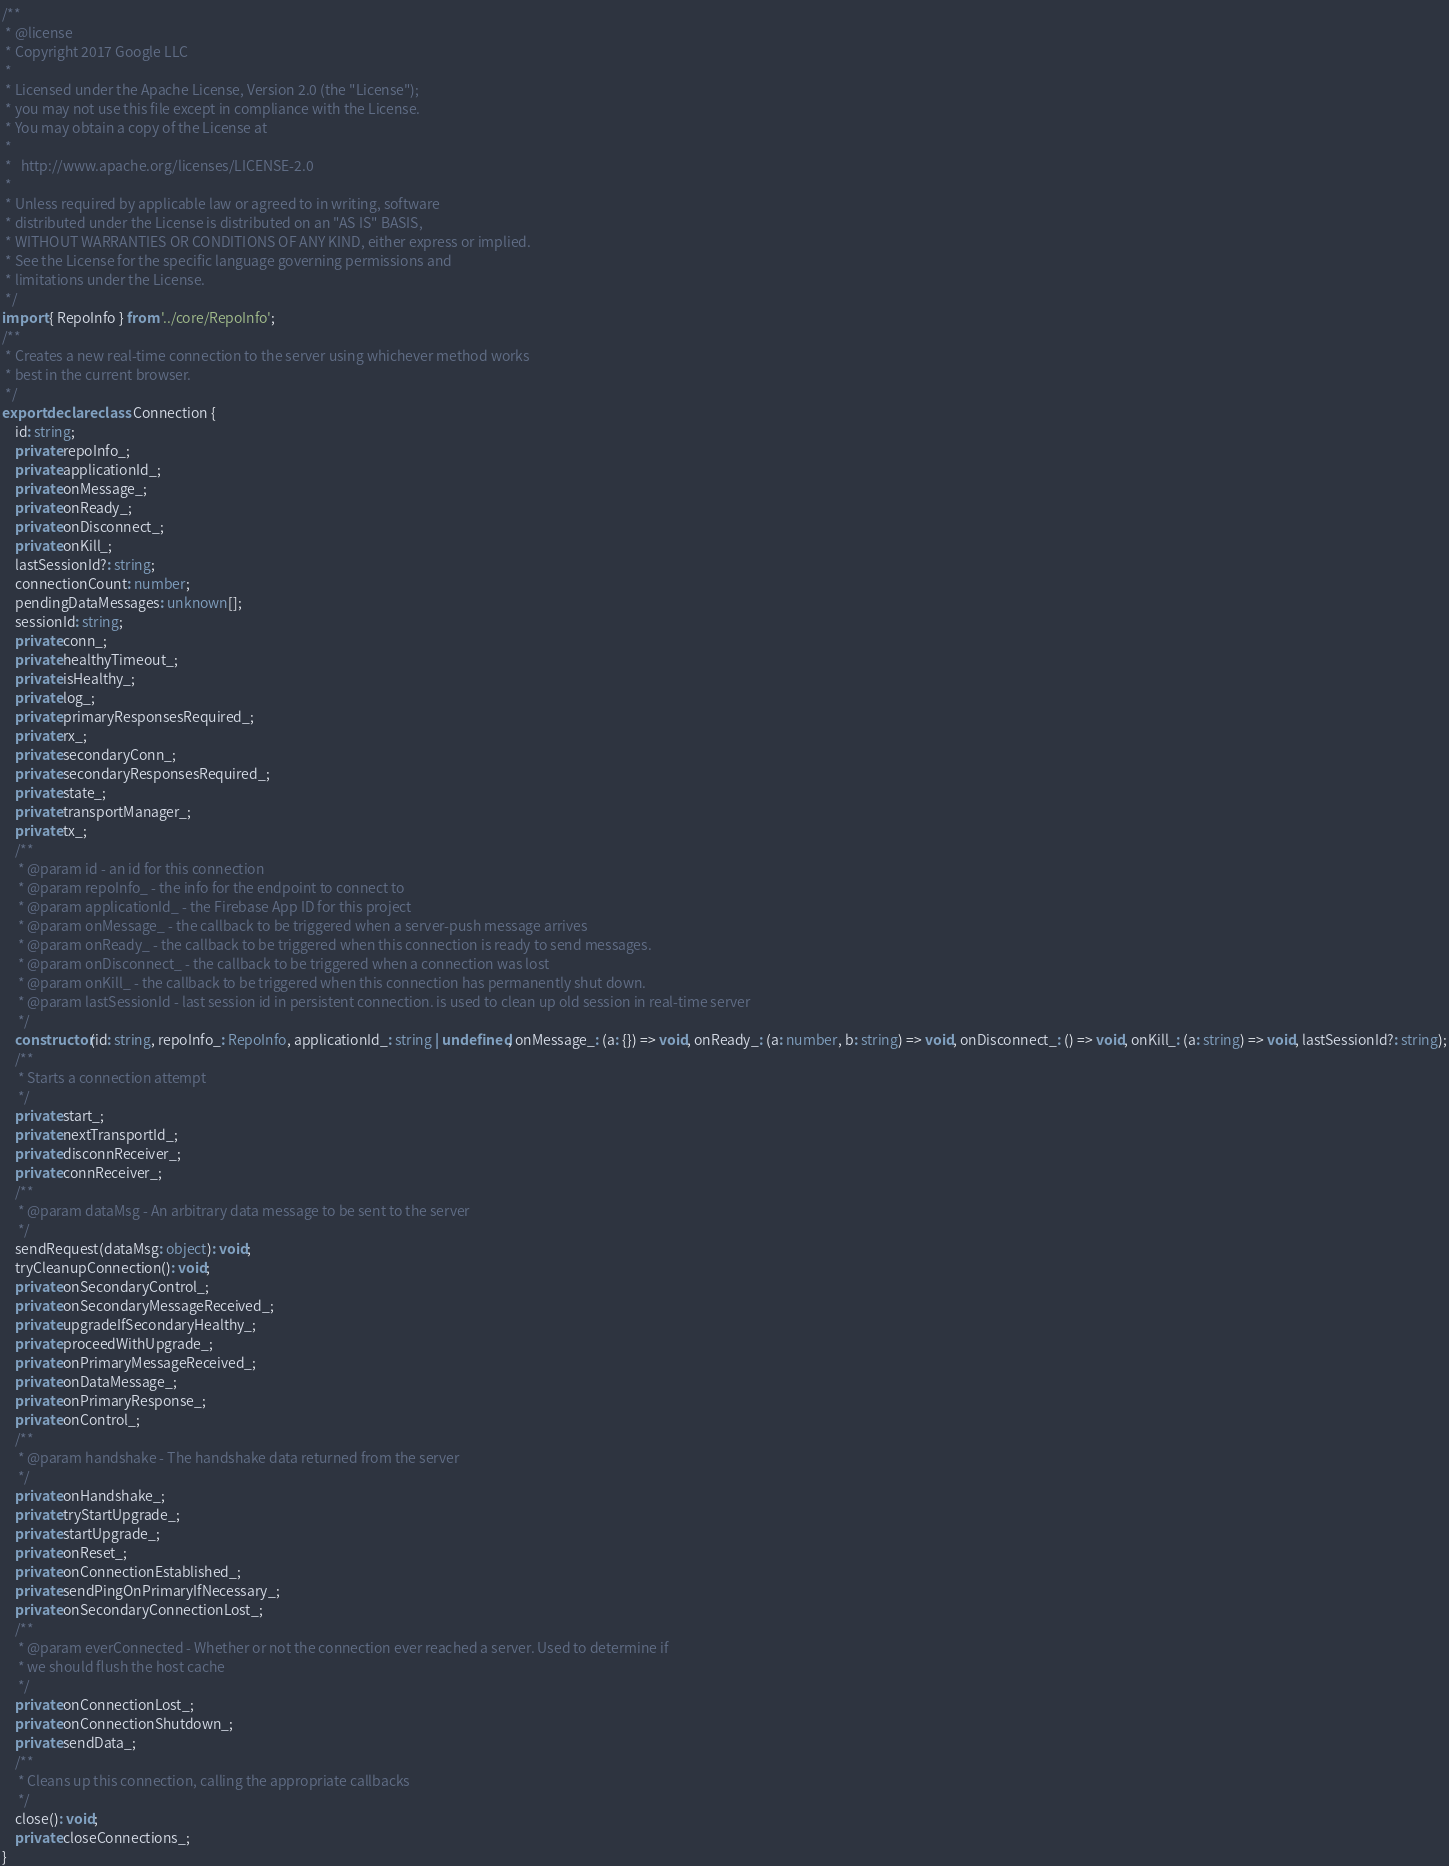<code> <loc_0><loc_0><loc_500><loc_500><_TypeScript_>/**
 * @license
 * Copyright 2017 Google LLC
 *
 * Licensed under the Apache License, Version 2.0 (the "License");
 * you may not use this file except in compliance with the License.
 * You may obtain a copy of the License at
 *
 *   http://www.apache.org/licenses/LICENSE-2.0
 *
 * Unless required by applicable law or agreed to in writing, software
 * distributed under the License is distributed on an "AS IS" BASIS,
 * WITHOUT WARRANTIES OR CONDITIONS OF ANY KIND, either express or implied.
 * See the License for the specific language governing permissions and
 * limitations under the License.
 */
import { RepoInfo } from '../core/RepoInfo';
/**
 * Creates a new real-time connection to the server using whichever method works
 * best in the current browser.
 */
export declare class Connection {
    id: string;
    private repoInfo_;
    private applicationId_;
    private onMessage_;
    private onReady_;
    private onDisconnect_;
    private onKill_;
    lastSessionId?: string;
    connectionCount: number;
    pendingDataMessages: unknown[];
    sessionId: string;
    private conn_;
    private healthyTimeout_;
    private isHealthy_;
    private log_;
    private primaryResponsesRequired_;
    private rx_;
    private secondaryConn_;
    private secondaryResponsesRequired_;
    private state_;
    private transportManager_;
    private tx_;
    /**
     * @param id - an id for this connection
     * @param repoInfo_ - the info for the endpoint to connect to
     * @param applicationId_ - the Firebase App ID for this project
     * @param onMessage_ - the callback to be triggered when a server-push message arrives
     * @param onReady_ - the callback to be triggered when this connection is ready to send messages.
     * @param onDisconnect_ - the callback to be triggered when a connection was lost
     * @param onKill_ - the callback to be triggered when this connection has permanently shut down.
     * @param lastSessionId - last session id in persistent connection. is used to clean up old session in real-time server
     */
    constructor(id: string, repoInfo_: RepoInfo, applicationId_: string | undefined, onMessage_: (a: {}) => void, onReady_: (a: number, b: string) => void, onDisconnect_: () => void, onKill_: (a: string) => void, lastSessionId?: string);
    /**
     * Starts a connection attempt
     */
    private start_;
    private nextTransportId_;
    private disconnReceiver_;
    private connReceiver_;
    /**
     * @param dataMsg - An arbitrary data message to be sent to the server
     */
    sendRequest(dataMsg: object): void;
    tryCleanupConnection(): void;
    private onSecondaryControl_;
    private onSecondaryMessageReceived_;
    private upgradeIfSecondaryHealthy_;
    private proceedWithUpgrade_;
    private onPrimaryMessageReceived_;
    private onDataMessage_;
    private onPrimaryResponse_;
    private onControl_;
    /**
     * @param handshake - The handshake data returned from the server
     */
    private onHandshake_;
    private tryStartUpgrade_;
    private startUpgrade_;
    private onReset_;
    private onConnectionEstablished_;
    private sendPingOnPrimaryIfNecessary_;
    private onSecondaryConnectionLost_;
    /**
     * @param everConnected - Whether or not the connection ever reached a server. Used to determine if
     * we should flush the host cache
     */
    private onConnectionLost_;
    private onConnectionShutdown_;
    private sendData_;
    /**
     * Cleans up this connection, calling the appropriate callbacks
     */
    close(): void;
    private closeConnections_;
}
</code> 